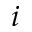<formula> <loc_0><loc_0><loc_500><loc_500>i</formula> 